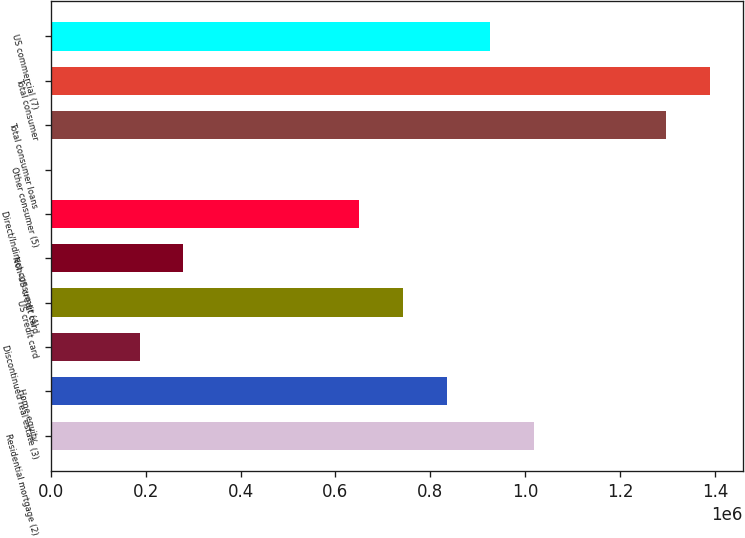Convert chart. <chart><loc_0><loc_0><loc_500><loc_500><bar_chart><fcel>Residential mortgage (2)<fcel>Home equity<fcel>Discontinued real estate (3)<fcel>US credit card<fcel>Non-US credit card<fcel>Direct/Indirect consumer (4)<fcel>Other consumer (5)<fcel>Total consumer loans<fcel>Total consumer<fcel>US commercial (7)<nl><fcel>1.01855e+06<fcel>833849<fcel>187390<fcel>741498<fcel>279742<fcel>649146<fcel>2688<fcel>1.2956e+06<fcel>1.38796e+06<fcel>926200<nl></chart> 